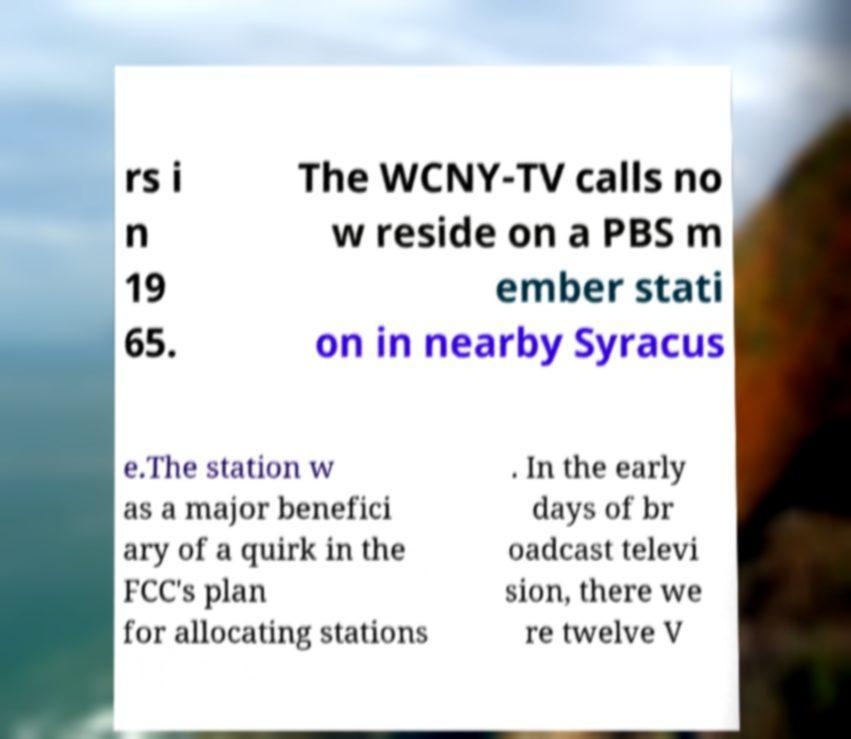I need the written content from this picture converted into text. Can you do that? rs i n 19 65. The WCNY-TV calls no w reside on a PBS m ember stati on in nearby Syracus e.The station w as a major benefici ary of a quirk in the FCC's plan for allocating stations . In the early days of br oadcast televi sion, there we re twelve V 